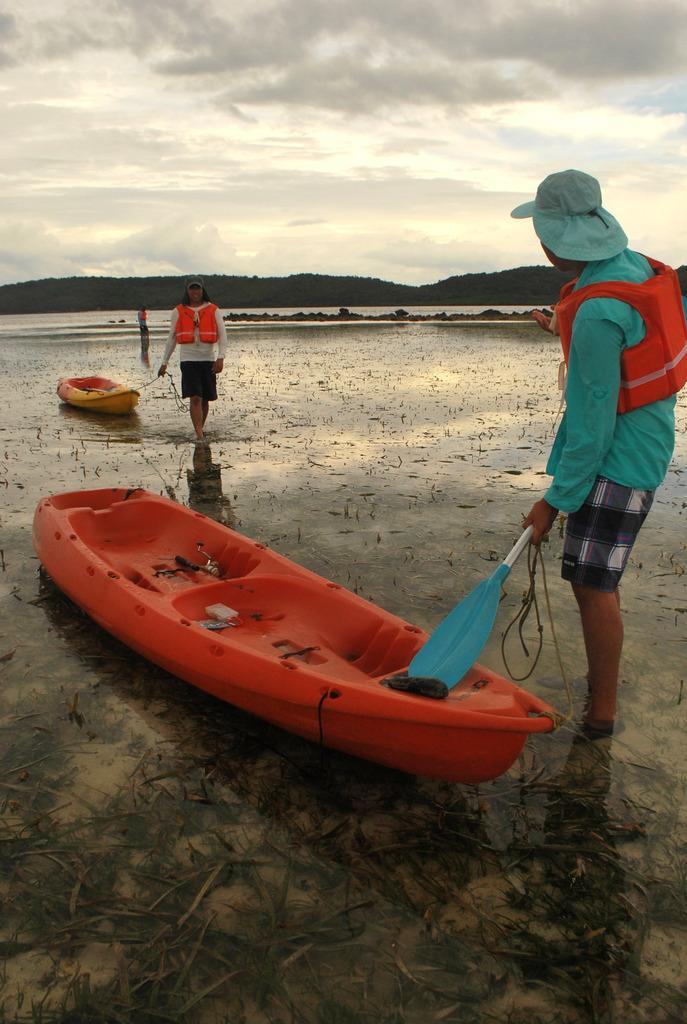Describe this image in one or two sentences. In this image I can see two persons. In front the person is wearing green color shirt, black and white short and holding a pedal which is in blue color and I can see boats in orange color. Background I can see water, mountains and the sky is in white color. 